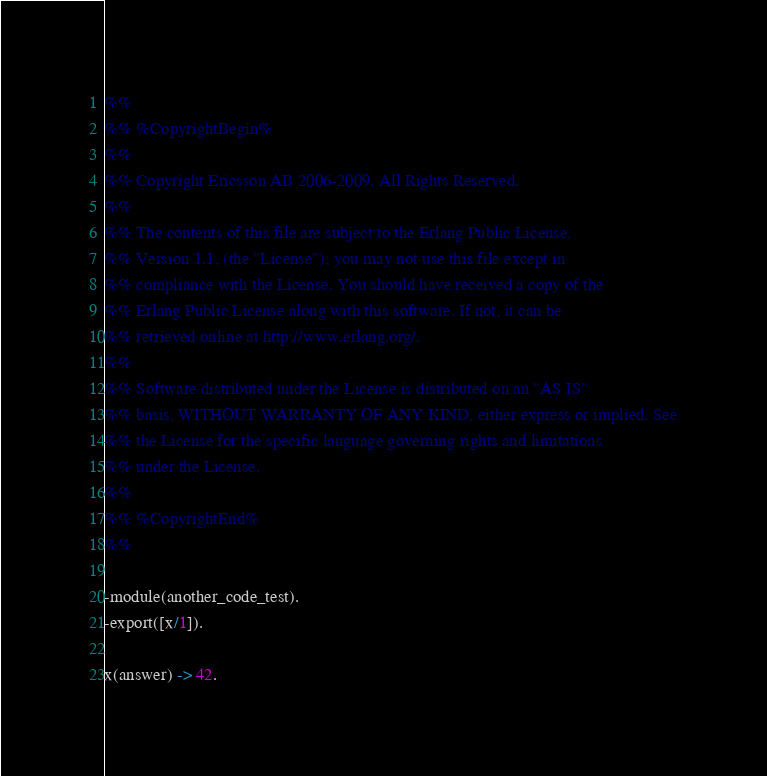Convert code to text. <code><loc_0><loc_0><loc_500><loc_500><_Erlang_>%%
%% %CopyrightBegin%
%% 
%% Copyright Ericsson AB 2006-2009. All Rights Reserved.
%% 
%% The contents of this file are subject to the Erlang Public License,
%% Version 1.1, (the "License"); you may not use this file except in
%% compliance with the License. You should have received a copy of the
%% Erlang Public License along with this software. If not, it can be
%% retrieved online at http://www.erlang.org/.
%% 
%% Software distributed under the License is distributed on an "AS IS"
%% basis, WITHOUT WARRANTY OF ANY KIND, either express or implied. See
%% the License for the specific language governing rights and limitations
%% under the License.
%% 
%% %CopyrightEnd%
%%

-module(another_code_test).
-export([x/1]).

x(answer) -> 42.
</code> 